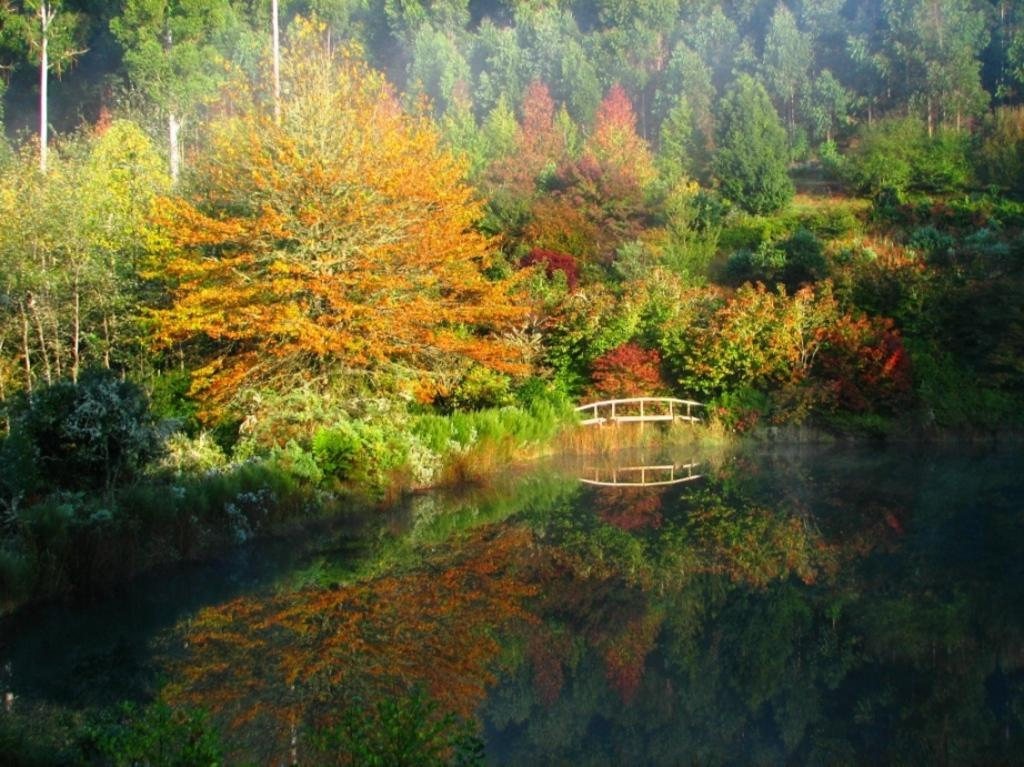What type of vegetation can be seen in the image? There are trees in the image. What is located in the middle of the image? There is water and railing in the middle of the image. How many teeth can be seen in the image? There are no teeth present in the image. What sense is being stimulated by the objects in the image? The provided facts do not give information about senses being stimulated by the objects in the image. 